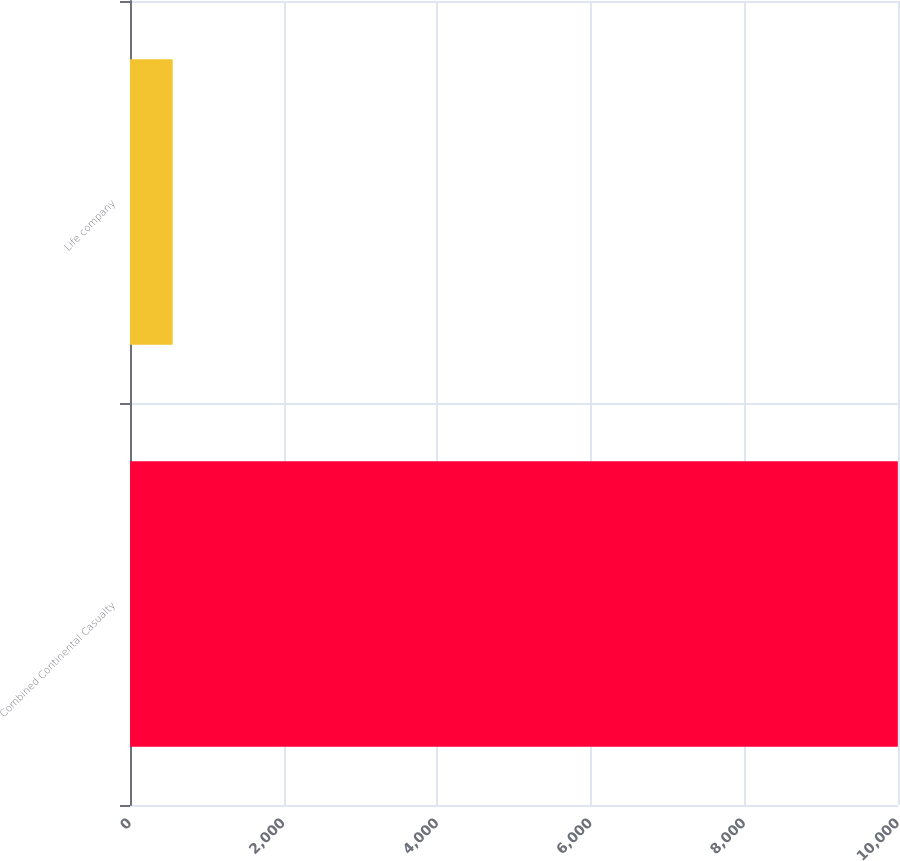<chart> <loc_0><loc_0><loc_500><loc_500><bar_chart><fcel>Combined Continental Casualty<fcel>Life company<nl><fcel>9998<fcel>556<nl></chart> 